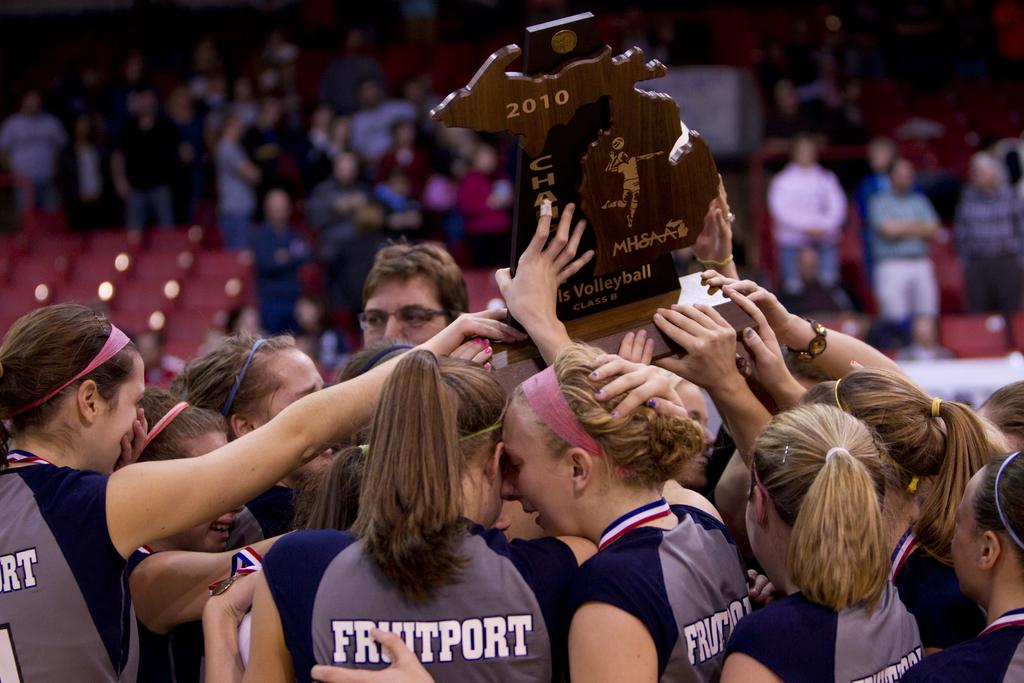<image>
Present a compact description of the photo's key features. Women holding up a basketball trophy and are wearing "Fruitport" jerseys 